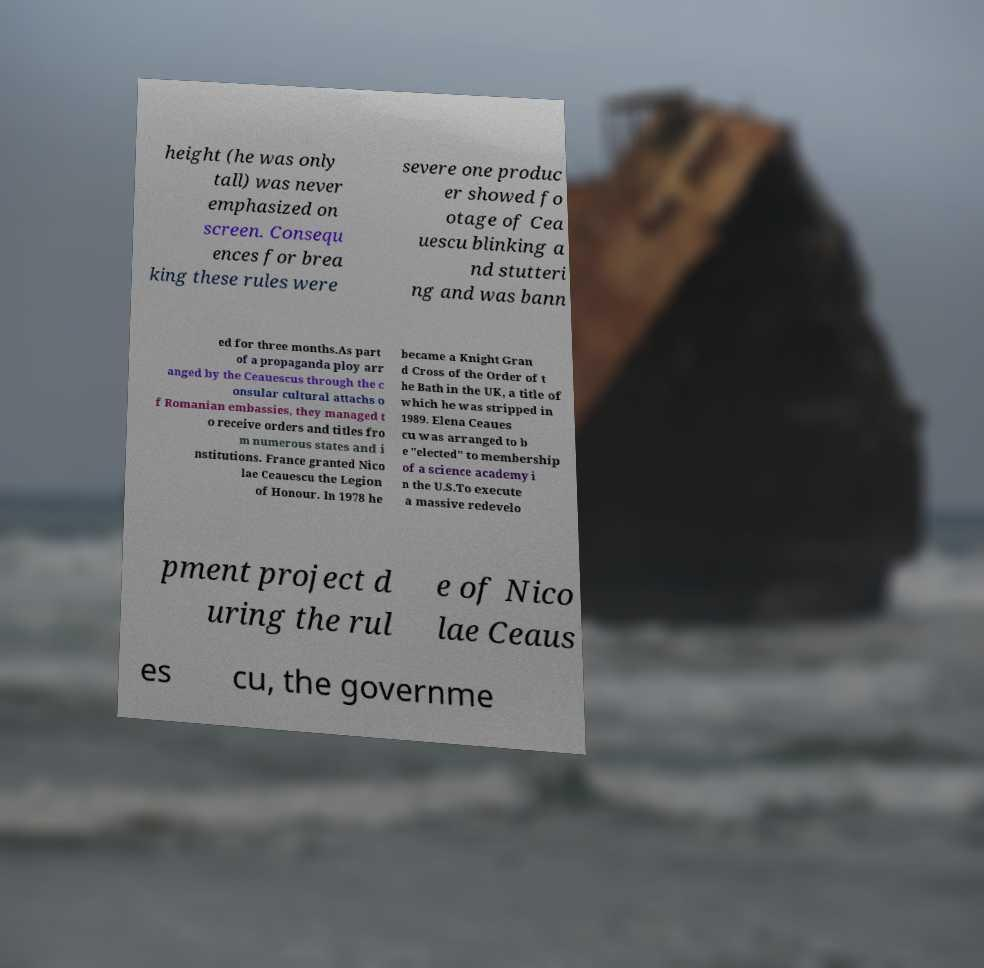What messages or text are displayed in this image? I need them in a readable, typed format. height (he was only tall) was never emphasized on screen. Consequ ences for brea king these rules were severe one produc er showed fo otage of Cea uescu blinking a nd stutteri ng and was bann ed for three months.As part of a propaganda ploy arr anged by the Ceauescus through the c onsular cultural attachs o f Romanian embassies, they managed t o receive orders and titles fro m numerous states and i nstitutions. France granted Nico lae Ceauescu the Legion of Honour. In 1978 he became a Knight Gran d Cross of the Order of t he Bath in the UK, a title of which he was stripped in 1989. Elena Ceaues cu was arranged to b e "elected" to membership of a science academy i n the U.S.To execute a massive redevelo pment project d uring the rul e of Nico lae Ceaus es cu, the governme 